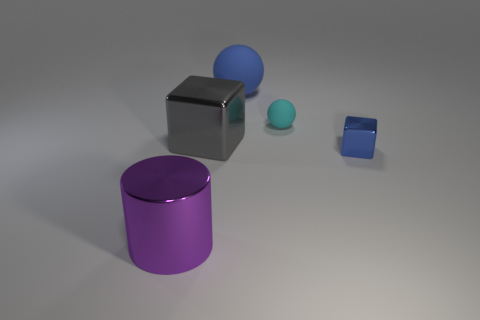Add 1 tiny brown spheres. How many objects exist? 6 Subtract all cylinders. How many objects are left? 4 Subtract 0 blue cylinders. How many objects are left? 5 Subtract all big yellow cylinders. Subtract all cyan objects. How many objects are left? 4 Add 5 blue rubber balls. How many blue rubber balls are left? 6 Add 1 purple cylinders. How many purple cylinders exist? 2 